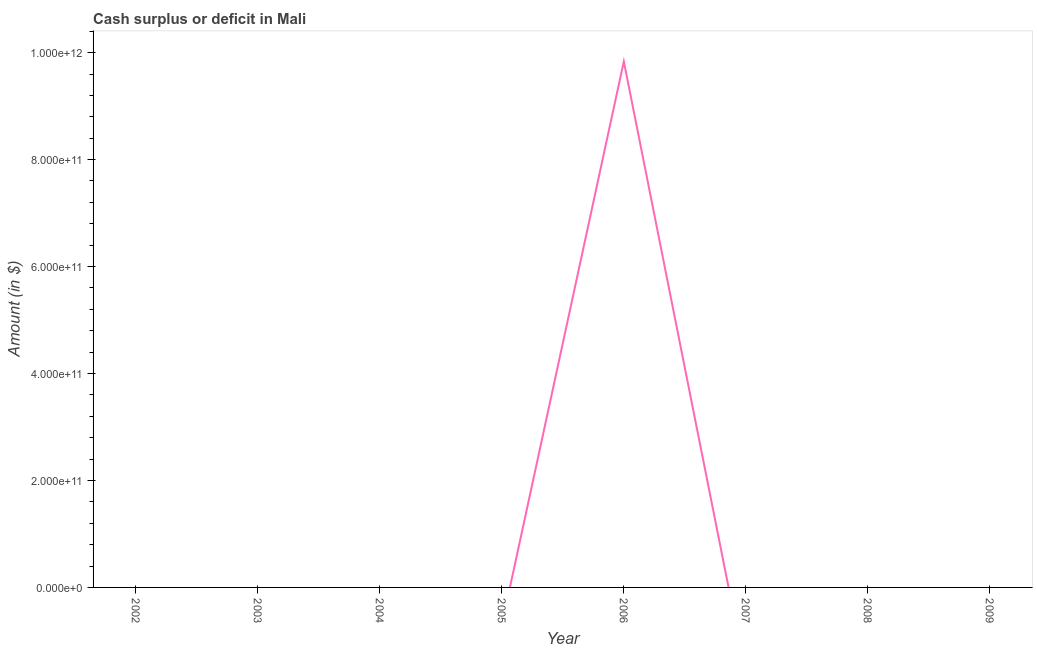Across all years, what is the maximum cash surplus or deficit?
Your response must be concise. 9.83e+11. What is the sum of the cash surplus or deficit?
Provide a short and direct response. 9.83e+11. What is the average cash surplus or deficit per year?
Make the answer very short. 1.23e+11. What is the difference between the highest and the lowest cash surplus or deficit?
Offer a very short reply. 9.83e+11. Does the cash surplus or deficit monotonically increase over the years?
Ensure brevity in your answer.  No. How many lines are there?
Your response must be concise. 1. How many years are there in the graph?
Offer a terse response. 8. What is the difference between two consecutive major ticks on the Y-axis?
Provide a succinct answer. 2.00e+11. What is the title of the graph?
Offer a terse response. Cash surplus or deficit in Mali. What is the label or title of the Y-axis?
Offer a terse response. Amount (in $). What is the Amount (in $) in 2002?
Provide a short and direct response. 0. What is the Amount (in $) of 2003?
Provide a short and direct response. 0. What is the Amount (in $) of 2005?
Keep it short and to the point. 0. What is the Amount (in $) in 2006?
Offer a very short reply. 9.83e+11. What is the Amount (in $) of 2009?
Ensure brevity in your answer.  0. 